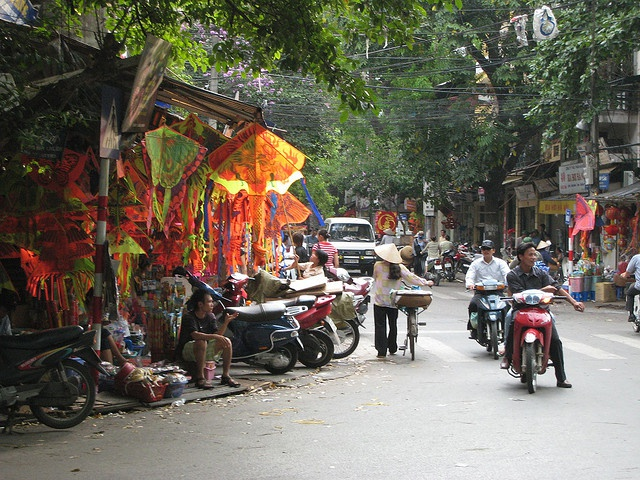Describe the objects in this image and their specific colors. I can see motorcycle in lightgray, black, gray, and maroon tones, kite in lightgray, red, brown, maroon, and khaki tones, motorcycle in lightgray, black, gray, white, and darkgray tones, kite in lightgray, black, maroon, brown, and darkgreen tones, and motorcycle in lightgray, black, maroon, gray, and white tones in this image. 